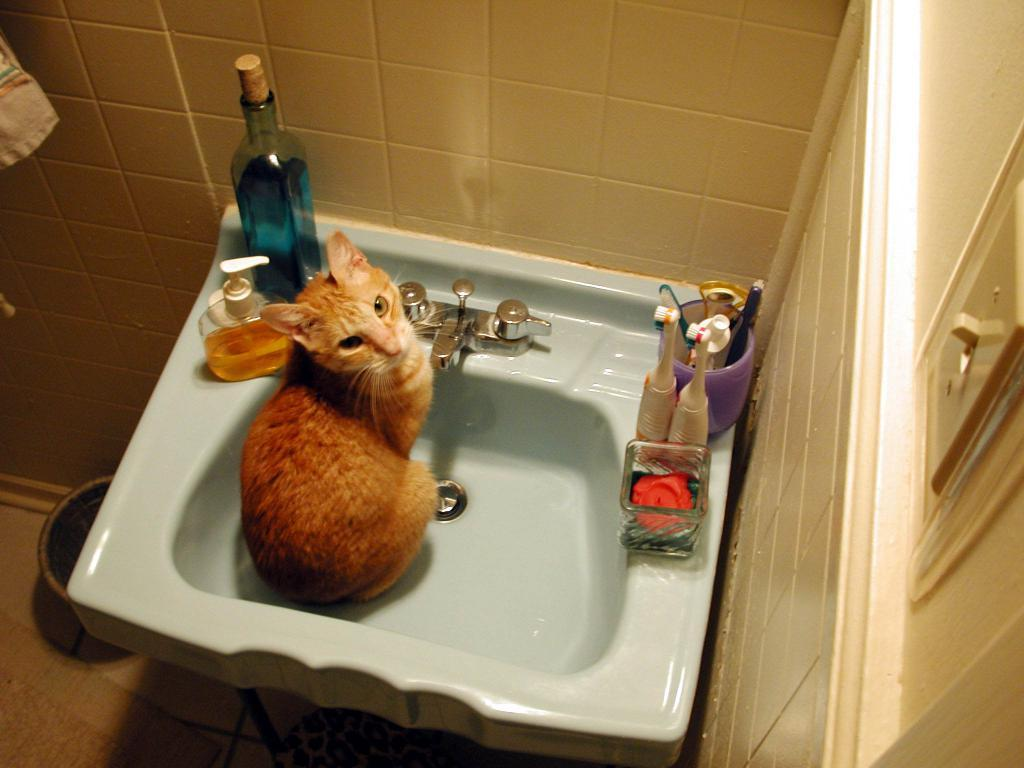What can be found in the image that is typically used for washing? There is a sink in the image that is typically used for washing. What items are placed on the sink? There are brushes and bottles on the sink. What type of animal is present in the image? There is a cat in the image. What is the background of the image made of? There is a wall in the image. What container is placed below the sink? There is a bucket below the sink. What type of straw is the cat using to drink from the bucket? There is no straw present in the image, and the cat is not drinking from the bucket. 